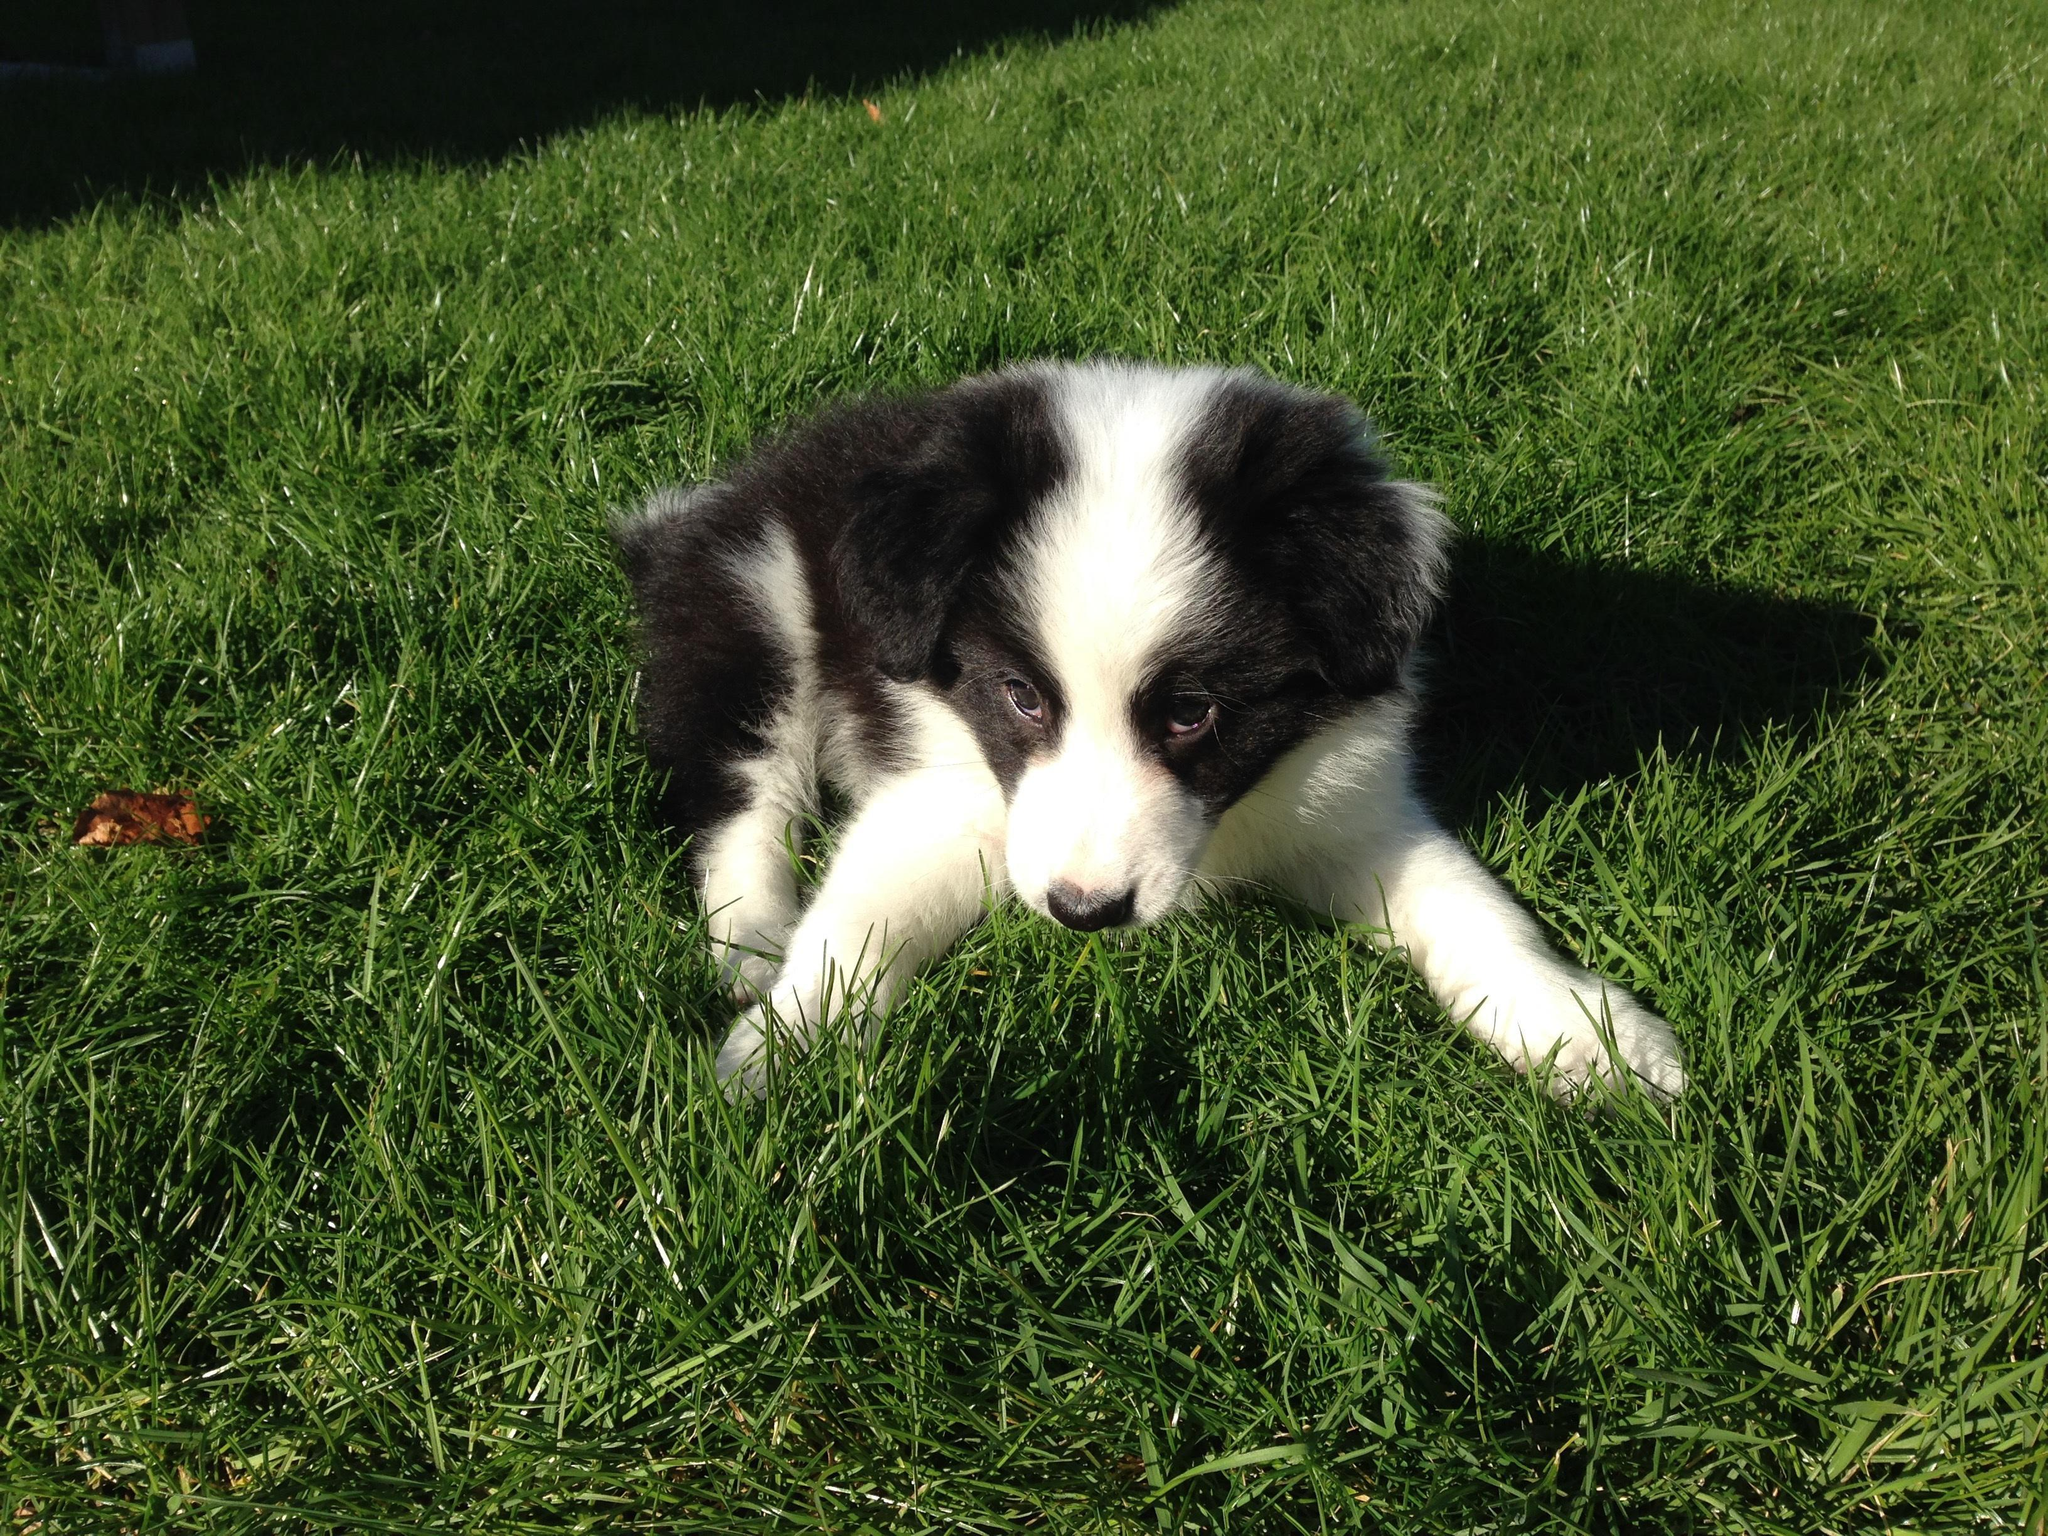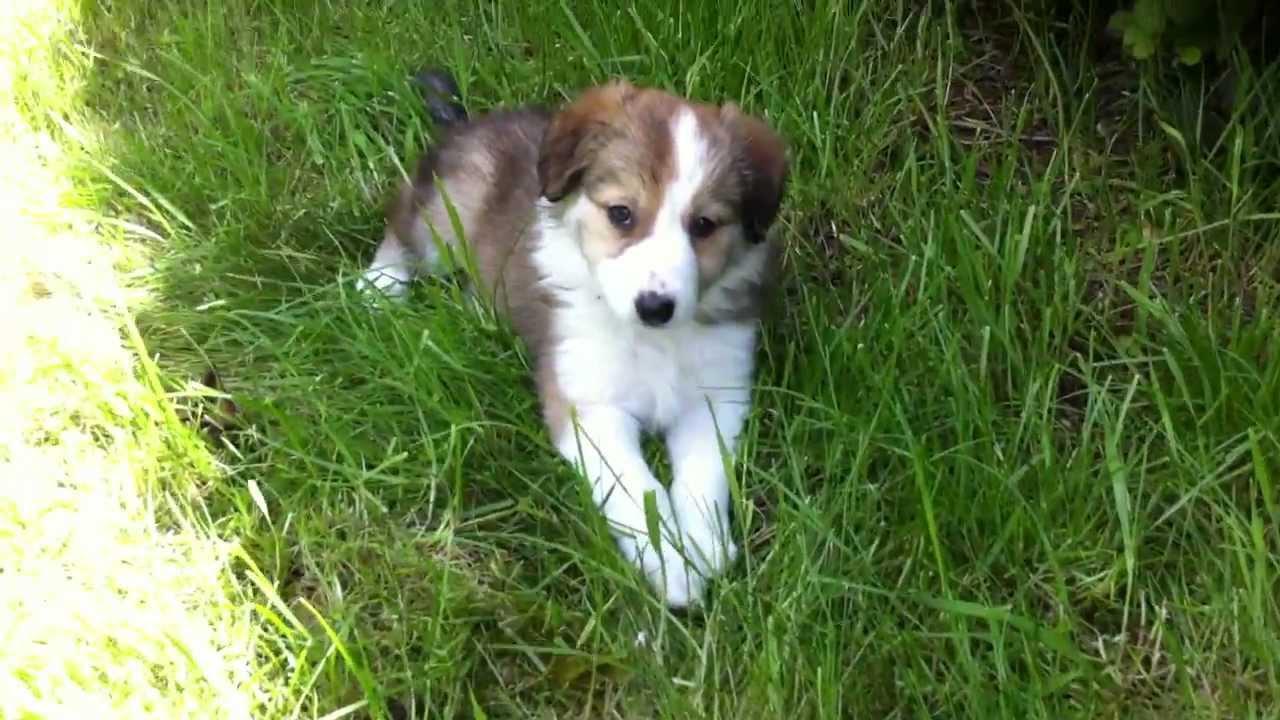The first image is the image on the left, the second image is the image on the right. For the images shown, is this caption "There are at least seven dogs in the image on the right." true? Answer yes or no. No. 